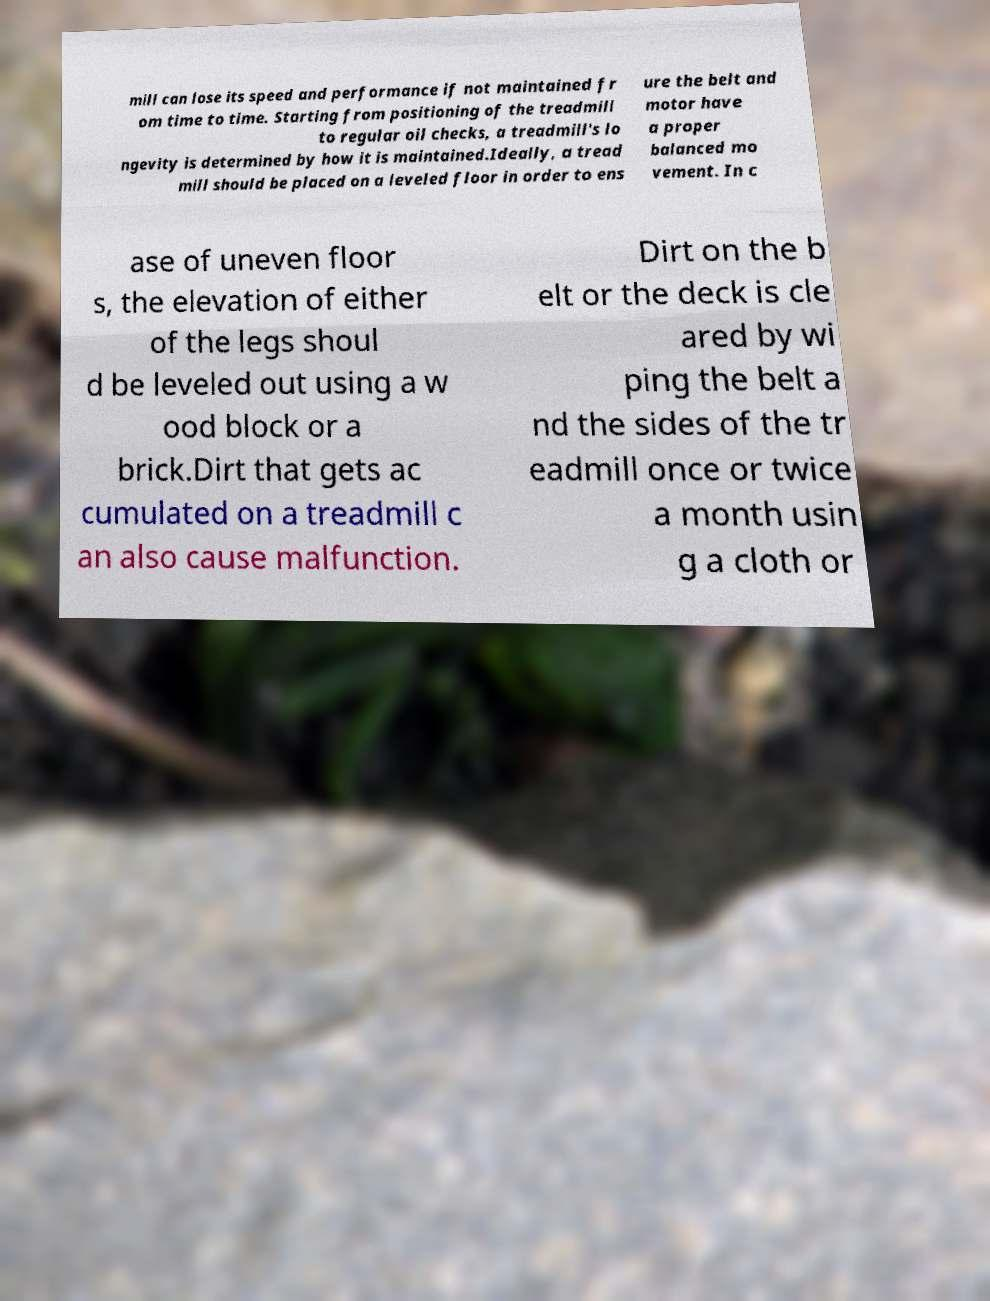Please identify and transcribe the text found in this image. mill can lose its speed and performance if not maintained fr om time to time. Starting from positioning of the treadmill to regular oil checks, a treadmill's lo ngevity is determined by how it is maintained.Ideally, a tread mill should be placed on a leveled floor in order to ens ure the belt and motor have a proper balanced mo vement. In c ase of uneven floor s, the elevation of either of the legs shoul d be leveled out using a w ood block or a brick.Dirt that gets ac cumulated on a treadmill c an also cause malfunction. Dirt on the b elt or the deck is cle ared by wi ping the belt a nd the sides of the tr eadmill once or twice a month usin g a cloth or 